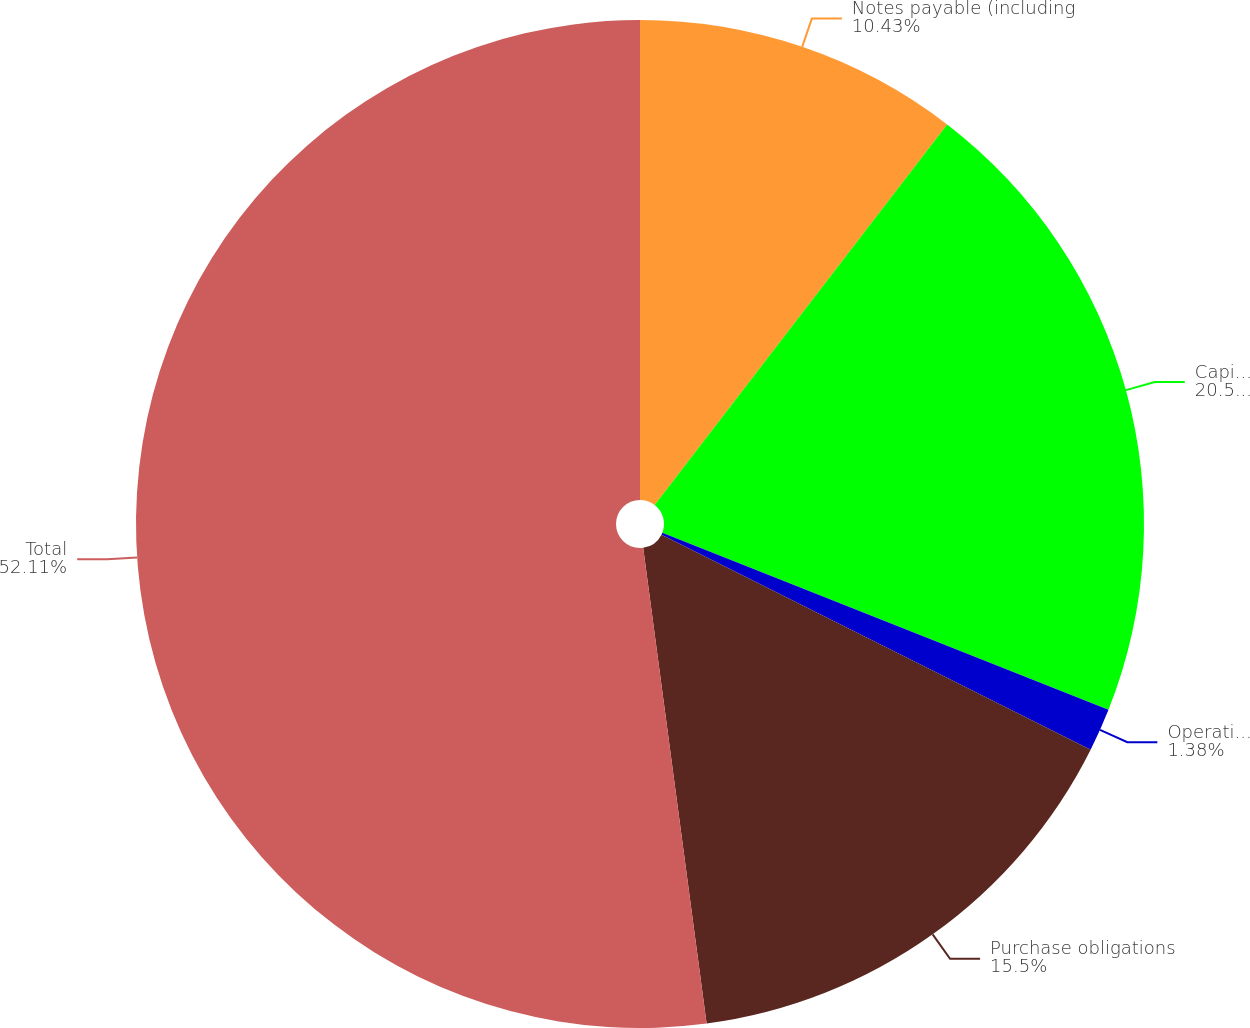<chart> <loc_0><loc_0><loc_500><loc_500><pie_chart><fcel>Notes payable (including<fcel>Capital lease obligations<fcel>Operating leases<fcel>Purchase obligations<fcel>Total<nl><fcel>10.43%<fcel>20.58%<fcel>1.38%<fcel>15.5%<fcel>52.11%<nl></chart> 